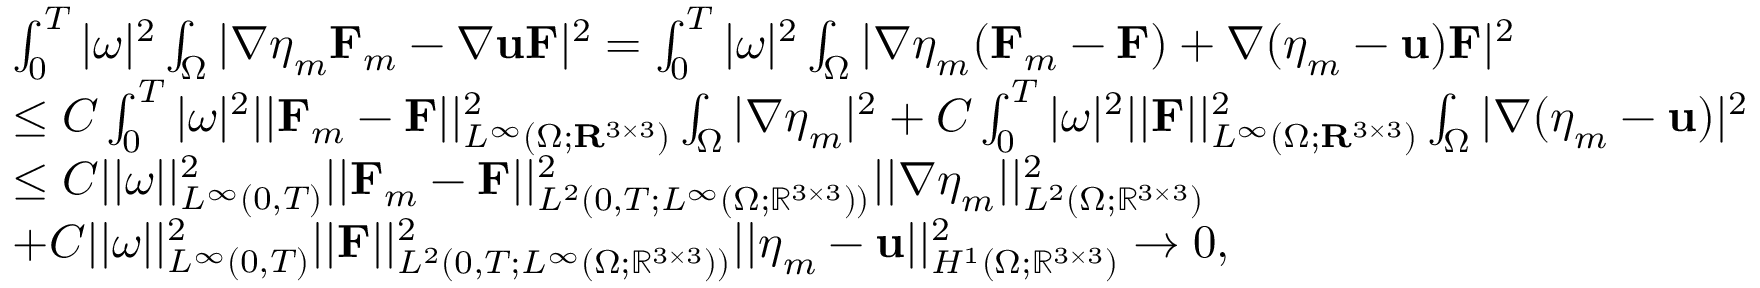<formula> <loc_0><loc_0><loc_500><loc_500>\begin{array} { r l } & { \int _ { 0 } ^ { T } | \omega | ^ { 2 } \int _ { \Omega } | \nabla \eta _ { m } F _ { m } - \nabla u F | ^ { 2 } = \int _ { 0 } ^ { T } | \omega | ^ { 2 } \int _ { \Omega } | \nabla \eta _ { m } ( F _ { m } - F ) + \nabla ( \eta _ { m } - u ) F | ^ { 2 } } \\ & { \leq C \int _ { 0 } ^ { T } | \omega | ^ { 2 } | | F _ { m } - F | | _ { L ^ { \infty } ( \Omega ; R ^ { 3 \times 3 } ) } ^ { 2 } \int _ { \Omega } | \nabla \eta _ { m } | ^ { 2 } + C \int _ { 0 } ^ { T } | \omega | ^ { 2 } | | F | | _ { L ^ { \infty } ( \Omega ; R ^ { 3 \times 3 } ) } ^ { 2 } \int _ { \Omega } | \nabla ( \eta _ { m } - u ) | ^ { 2 } } \\ & { \leq C | | \omega | | _ { L ^ { \infty } ( 0 , T ) } ^ { 2 } | | F _ { m } - F | | _ { L ^ { 2 } ( 0 , T ; L ^ { \infty } ( \Omega ; \mathbb { R } ^ { 3 \times 3 } ) ) } ^ { 2 } | | \nabla \eta _ { m } | | _ { L ^ { 2 } ( \Omega ; \mathbb { R } ^ { 3 \times 3 } ) } ^ { 2 } } \\ & { + C | | \omega | | _ { L ^ { \infty } ( 0 , T ) } ^ { 2 } | | F | | _ { L ^ { 2 } ( 0 , T ; L ^ { \infty } ( \Omega ; \mathbb { R } ^ { 3 \times 3 } ) ) } ^ { 2 } | | \eta _ { m } - u | | _ { H ^ { 1 } ( \Omega ; \mathbb { R } ^ { 3 \times 3 } ) } ^ { 2 } \to 0 , } \end{array}</formula> 